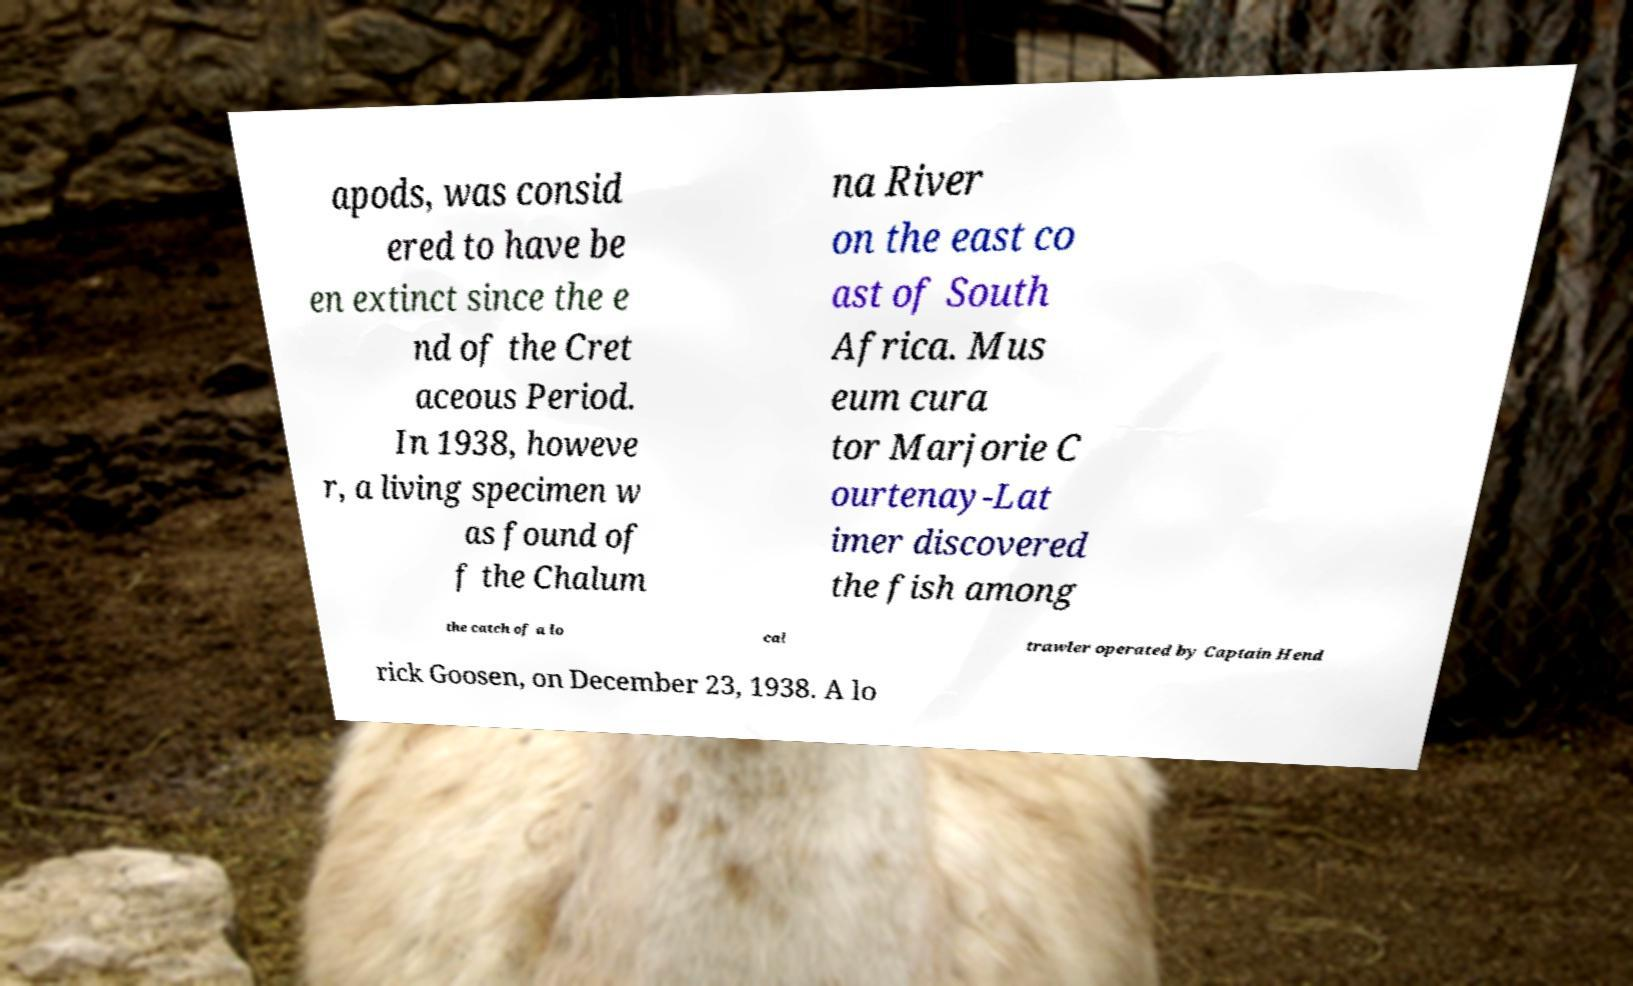Can you read and provide the text displayed in the image?This photo seems to have some interesting text. Can you extract and type it out for me? apods, was consid ered to have be en extinct since the e nd of the Cret aceous Period. In 1938, howeve r, a living specimen w as found of f the Chalum na River on the east co ast of South Africa. Mus eum cura tor Marjorie C ourtenay-Lat imer discovered the fish among the catch of a lo cal trawler operated by Captain Hend rick Goosen, on December 23, 1938. A lo 